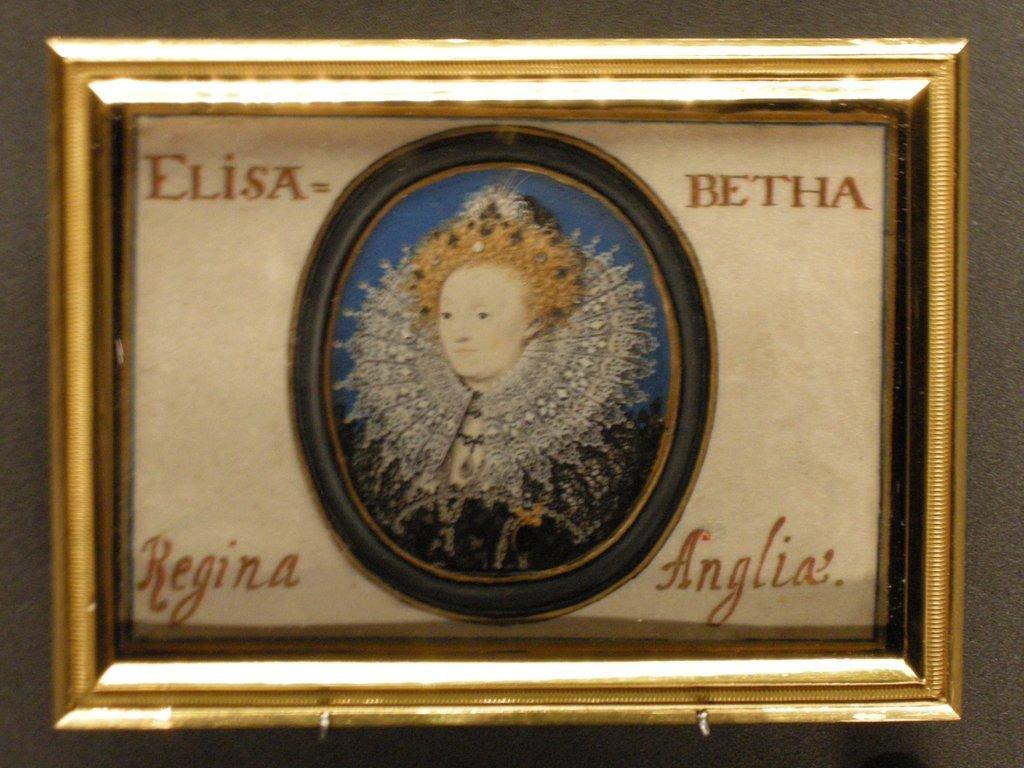<image>
Give a short and clear explanation of the subsequent image. A portrait of a Queen with Elisa and Betha at the top corners. 